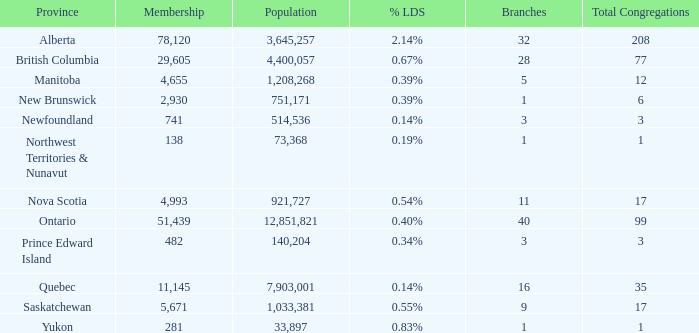What is the total number of congregants in the manitoba province with a population less than 1,208,268? None. 